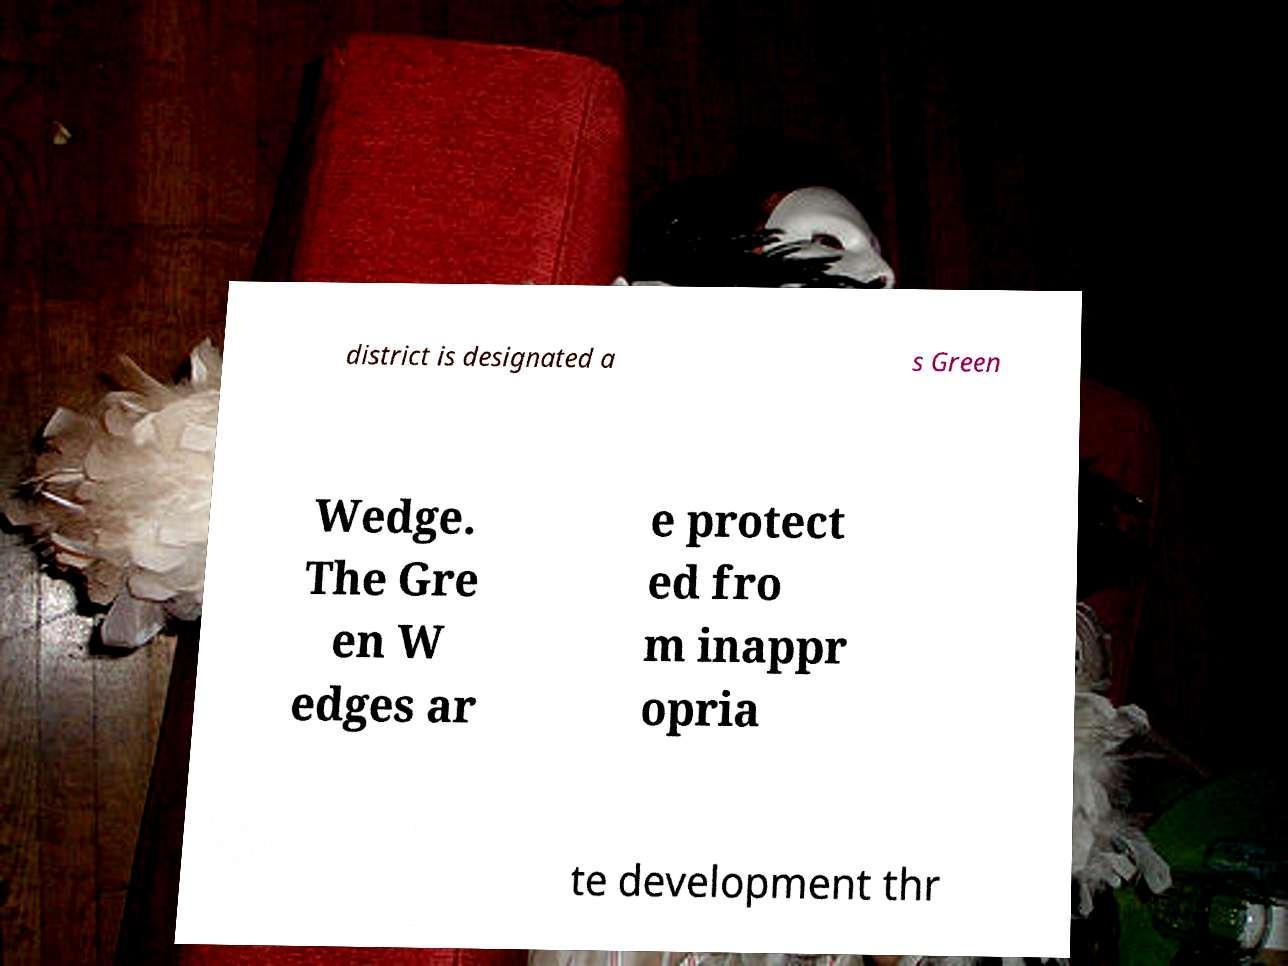Can you accurately transcribe the text from the provided image for me? district is designated a s Green Wedge. The Gre en W edges ar e protect ed fro m inappr opria te development thr 